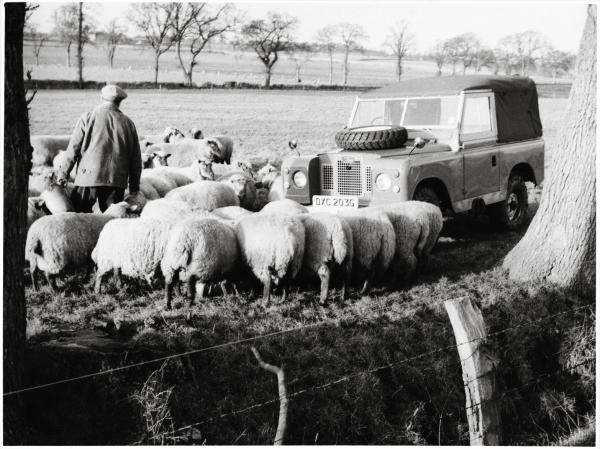Describe the objects in this image and their specific colors. I can see truck in lightgray, darkgray, black, and gray tones, sheep in lightgray, darkgray, black, and gray tones, people in lightgray, black, darkgray, and gray tones, sheep in lightgray, darkgray, black, and gray tones, and sheep in lightgray, gray, black, and darkgray tones in this image. 